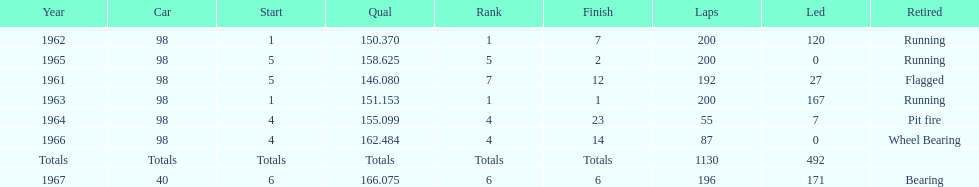What was his best finish before his first win? 7. 